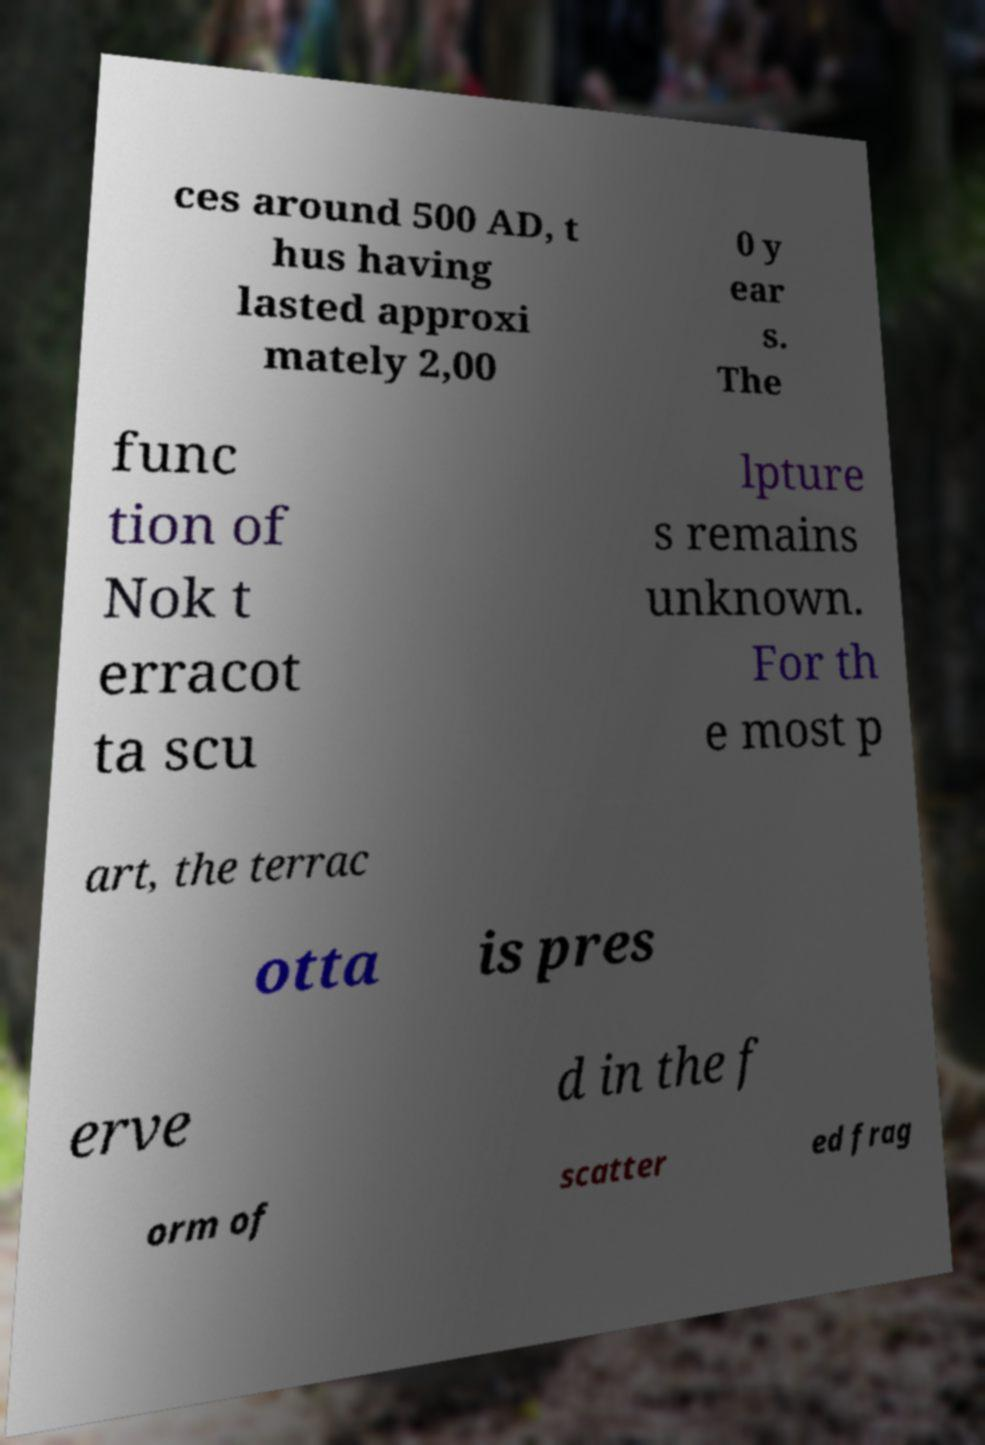For documentation purposes, I need the text within this image transcribed. Could you provide that? ces around 500 AD, t hus having lasted approxi mately 2,00 0 y ear s. The func tion of Nok t erracot ta scu lpture s remains unknown. For th e most p art, the terrac otta is pres erve d in the f orm of scatter ed frag 